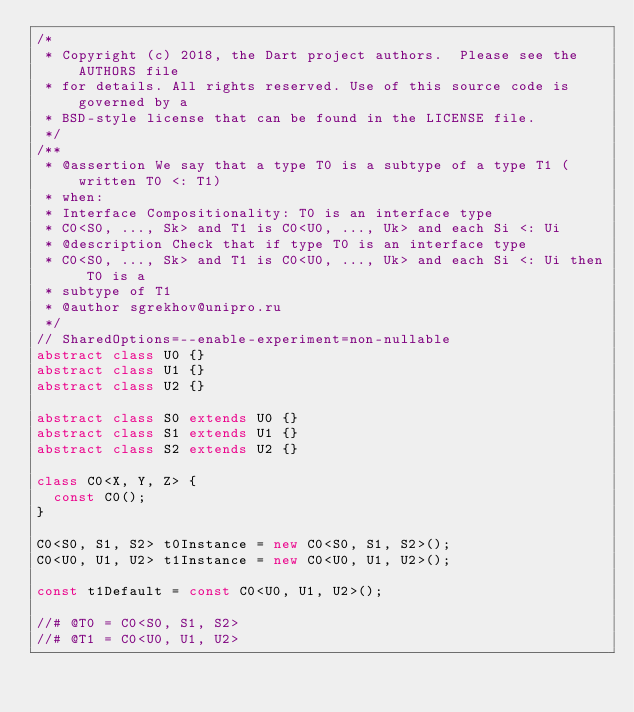Convert code to text. <code><loc_0><loc_0><loc_500><loc_500><_Dart_>/*
 * Copyright (c) 2018, the Dart project authors.  Please see the AUTHORS file
 * for details. All rights reserved. Use of this source code is governed by a
 * BSD-style license that can be found in the LICENSE file.
 */
/**
 * @assertion We say that a type T0 is a subtype of a type T1 (written T0 <: T1)
 * when:
 * Interface Compositionality: T0 is an interface type
 * C0<S0, ..., Sk> and T1 is C0<U0, ..., Uk> and each Si <: Ui
 * @description Check that if type T0 is an interface type
 * C0<S0, ..., Sk> and T1 is C0<U0, ..., Uk> and each Si <: Ui then T0 is a
 * subtype of T1
 * @author sgrekhov@unipro.ru
 */
// SharedOptions=--enable-experiment=non-nullable
abstract class U0 {}
abstract class U1 {}
abstract class U2 {}

abstract class S0 extends U0 {}
abstract class S1 extends U1 {}
abstract class S2 extends U2 {}

class C0<X, Y, Z> {
  const C0();
}

C0<S0, S1, S2> t0Instance = new C0<S0, S1, S2>();
C0<U0, U1, U2> t1Instance = new C0<U0, U1, U2>();

const t1Default = const C0<U0, U1, U2>();

//# @T0 = C0<S0, S1, S2>
//# @T1 = C0<U0, U1, U2>
</code> 